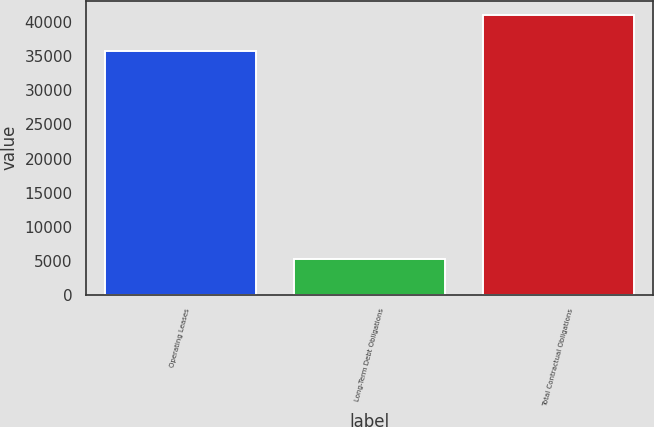Convert chart to OTSL. <chart><loc_0><loc_0><loc_500><loc_500><bar_chart><fcel>Operating Leases<fcel>Long-Term Debt Obligations<fcel>Total Contractual Obligations<nl><fcel>35830<fcel>5268<fcel>41098<nl></chart> 